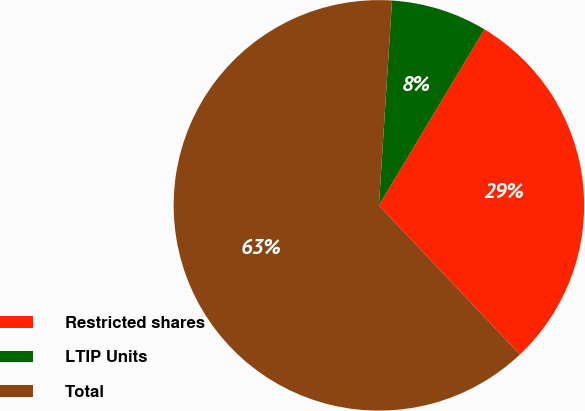Convert chart to OTSL. <chart><loc_0><loc_0><loc_500><loc_500><pie_chart><fcel>Restricted shares<fcel>LTIP Units<fcel>Total<nl><fcel>29.35%<fcel>7.57%<fcel>63.07%<nl></chart> 